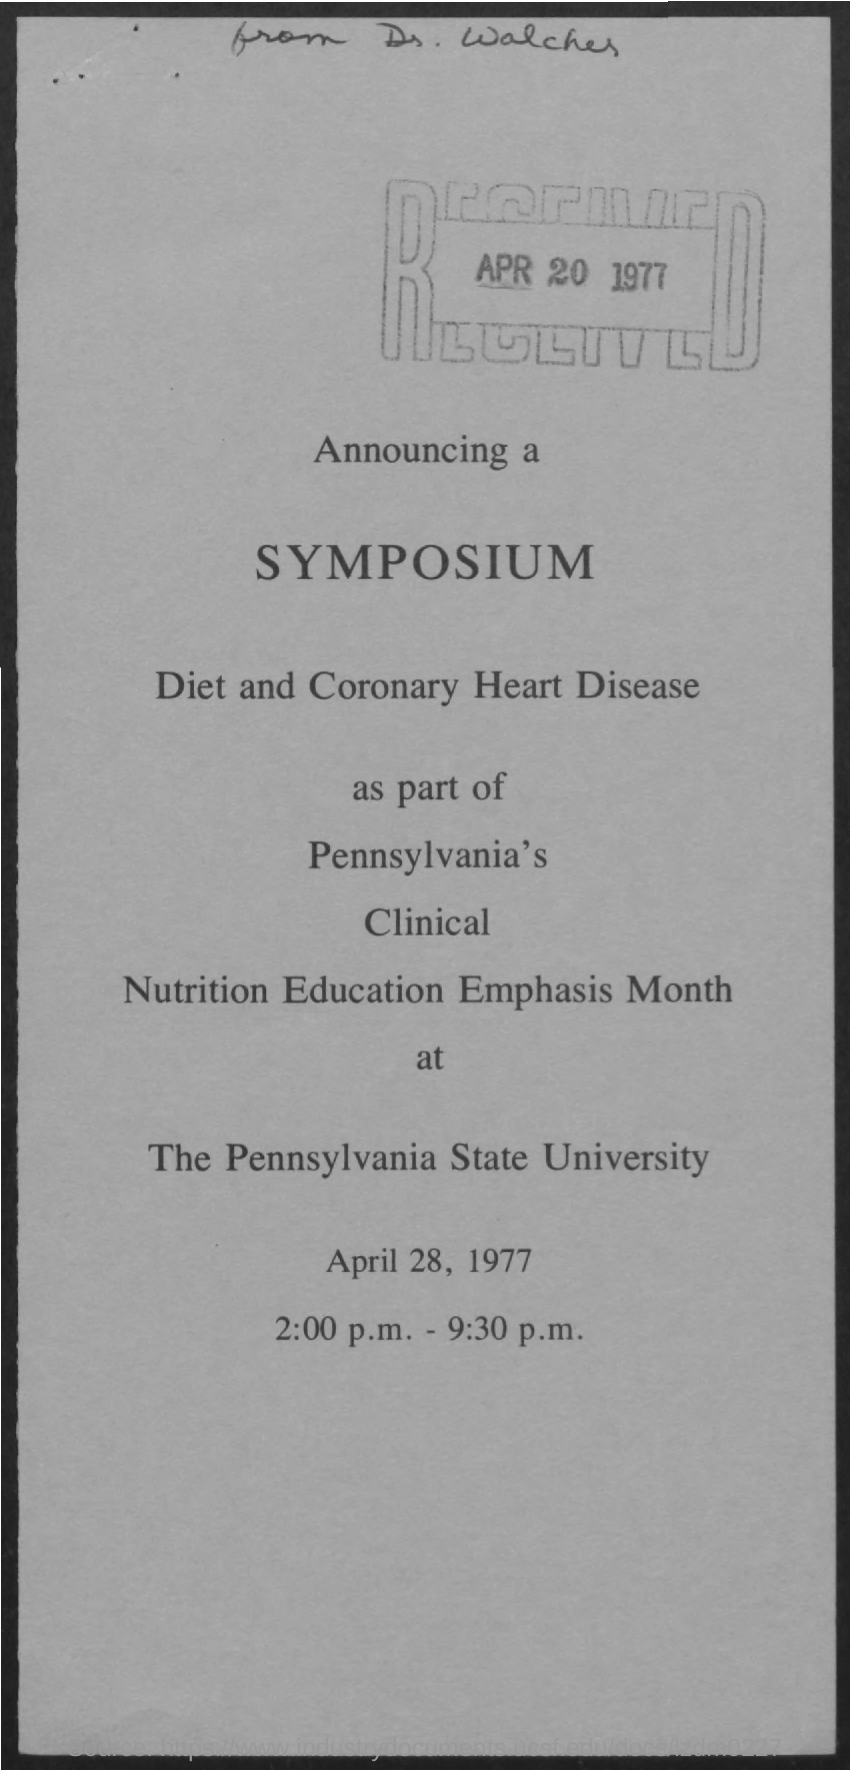List a handful of essential elements in this visual. The Pennsylvania State University is named in this announcement. On the date written in the rectangular box, which is APR 20 1977, the given text provides a question asking for information about a specific date. 